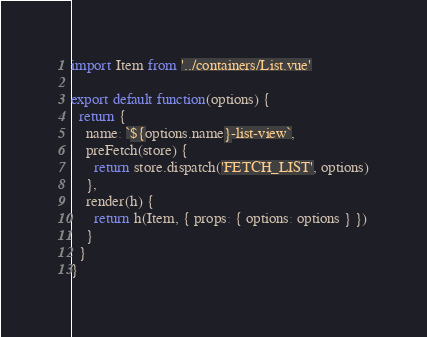Convert code to text. <code><loc_0><loc_0><loc_500><loc_500><_JavaScript_>import Item from '../containers/List.vue'

export default function(options) {
  return {
    name: `${options.name}-list-view`,
    preFetch(store) {
      return store.dispatch('FETCH_LIST', options)
    },
    render(h) {
      return h(Item, { props: { options: options } })
    }
  }
}
</code> 